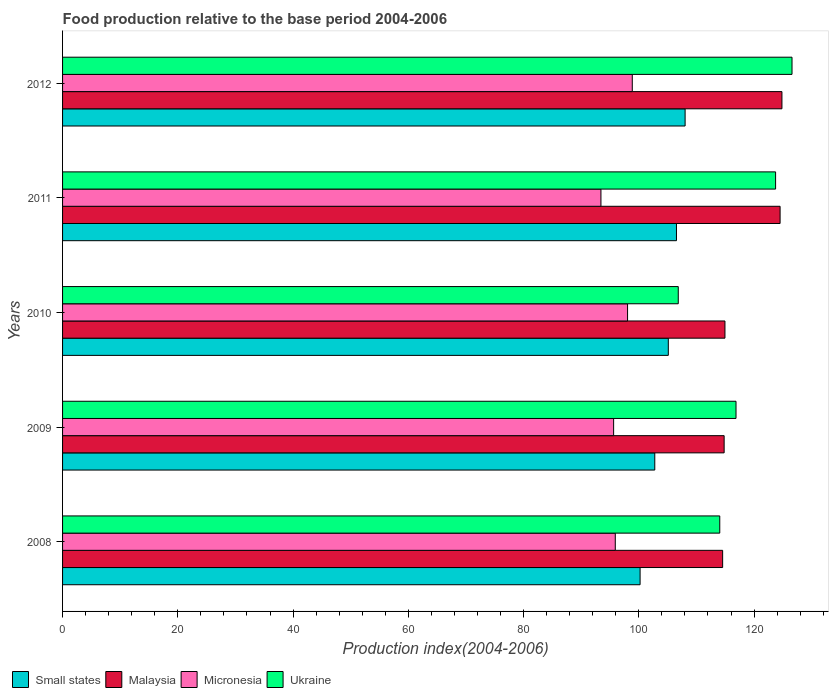Are the number of bars per tick equal to the number of legend labels?
Offer a terse response. Yes. Are the number of bars on each tick of the Y-axis equal?
Ensure brevity in your answer.  Yes. How many bars are there on the 2nd tick from the bottom?
Keep it short and to the point. 4. What is the food production index in Small states in 2011?
Your answer should be very brief. 106.54. Across all years, what is the maximum food production index in Ukraine?
Give a very brief answer. 126.59. Across all years, what is the minimum food production index in Malaysia?
Make the answer very short. 114.55. In which year was the food production index in Ukraine maximum?
Keep it short and to the point. 2012. In which year was the food production index in Small states minimum?
Offer a very short reply. 2008. What is the total food production index in Ukraine in the graph?
Your answer should be very brief. 588.1. What is the difference between the food production index in Small states in 2009 and that in 2011?
Give a very brief answer. -3.76. What is the difference between the food production index in Micronesia in 2010 and the food production index in Small states in 2008?
Keep it short and to the point. -2.17. What is the average food production index in Micronesia per year?
Your response must be concise. 96.38. In the year 2012, what is the difference between the food production index in Ukraine and food production index in Malaysia?
Give a very brief answer. 1.75. What is the ratio of the food production index in Micronesia in 2009 to that in 2012?
Give a very brief answer. 0.97. Is the food production index in Micronesia in 2011 less than that in 2012?
Your answer should be compact. Yes. What is the difference between the highest and the second highest food production index in Micronesia?
Make the answer very short. 0.82. What is the difference between the highest and the lowest food production index in Ukraine?
Provide a short and direct response. 19.74. In how many years, is the food production index in Ukraine greater than the average food production index in Ukraine taken over all years?
Give a very brief answer. 2. Is the sum of the food production index in Ukraine in 2008 and 2011 greater than the maximum food production index in Micronesia across all years?
Your response must be concise. Yes. Is it the case that in every year, the sum of the food production index in Ukraine and food production index in Small states is greater than the sum of food production index in Micronesia and food production index in Malaysia?
Provide a succinct answer. No. What does the 3rd bar from the top in 2012 represents?
Ensure brevity in your answer.  Malaysia. What does the 1st bar from the bottom in 2012 represents?
Keep it short and to the point. Small states. Is it the case that in every year, the sum of the food production index in Malaysia and food production index in Ukraine is greater than the food production index in Micronesia?
Your response must be concise. Yes. Are all the bars in the graph horizontal?
Your answer should be very brief. Yes. How many years are there in the graph?
Offer a very short reply. 5. Are the values on the major ticks of X-axis written in scientific E-notation?
Your answer should be compact. No. Does the graph contain any zero values?
Provide a short and direct response. No. Does the graph contain grids?
Provide a succinct answer. No. How many legend labels are there?
Your answer should be very brief. 4. What is the title of the graph?
Your answer should be compact. Food production relative to the base period 2004-2006. What is the label or title of the X-axis?
Ensure brevity in your answer.  Production index(2004-2006). What is the label or title of the Y-axis?
Your response must be concise. Years. What is the Production index(2004-2006) in Small states in 2008?
Offer a terse response. 100.22. What is the Production index(2004-2006) of Malaysia in 2008?
Offer a terse response. 114.55. What is the Production index(2004-2006) of Micronesia in 2008?
Your answer should be very brief. 95.92. What is the Production index(2004-2006) in Ukraine in 2008?
Offer a very short reply. 114.05. What is the Production index(2004-2006) of Small states in 2009?
Your answer should be very brief. 102.77. What is the Production index(2004-2006) of Malaysia in 2009?
Your answer should be compact. 114.81. What is the Production index(2004-2006) in Micronesia in 2009?
Make the answer very short. 95.63. What is the Production index(2004-2006) in Ukraine in 2009?
Make the answer very short. 116.87. What is the Production index(2004-2006) in Small states in 2010?
Offer a terse response. 105.12. What is the Production index(2004-2006) of Malaysia in 2010?
Your response must be concise. 114.95. What is the Production index(2004-2006) of Micronesia in 2010?
Make the answer very short. 98.05. What is the Production index(2004-2006) of Ukraine in 2010?
Your answer should be compact. 106.85. What is the Production index(2004-2006) in Small states in 2011?
Make the answer very short. 106.54. What is the Production index(2004-2006) in Malaysia in 2011?
Ensure brevity in your answer.  124.52. What is the Production index(2004-2006) in Micronesia in 2011?
Offer a very short reply. 93.43. What is the Production index(2004-2006) of Ukraine in 2011?
Offer a terse response. 123.74. What is the Production index(2004-2006) in Small states in 2012?
Offer a terse response. 108.04. What is the Production index(2004-2006) of Malaysia in 2012?
Ensure brevity in your answer.  124.84. What is the Production index(2004-2006) in Micronesia in 2012?
Your response must be concise. 98.87. What is the Production index(2004-2006) of Ukraine in 2012?
Give a very brief answer. 126.59. Across all years, what is the maximum Production index(2004-2006) in Small states?
Your answer should be compact. 108.04. Across all years, what is the maximum Production index(2004-2006) of Malaysia?
Your response must be concise. 124.84. Across all years, what is the maximum Production index(2004-2006) in Micronesia?
Your answer should be very brief. 98.87. Across all years, what is the maximum Production index(2004-2006) in Ukraine?
Ensure brevity in your answer.  126.59. Across all years, what is the minimum Production index(2004-2006) in Small states?
Offer a very short reply. 100.22. Across all years, what is the minimum Production index(2004-2006) of Malaysia?
Offer a terse response. 114.55. Across all years, what is the minimum Production index(2004-2006) of Micronesia?
Ensure brevity in your answer.  93.43. Across all years, what is the minimum Production index(2004-2006) of Ukraine?
Your answer should be compact. 106.85. What is the total Production index(2004-2006) of Small states in the graph?
Your answer should be compact. 522.69. What is the total Production index(2004-2006) in Malaysia in the graph?
Your answer should be compact. 593.67. What is the total Production index(2004-2006) in Micronesia in the graph?
Ensure brevity in your answer.  481.9. What is the total Production index(2004-2006) in Ukraine in the graph?
Give a very brief answer. 588.1. What is the difference between the Production index(2004-2006) in Small states in 2008 and that in 2009?
Offer a terse response. -2.55. What is the difference between the Production index(2004-2006) of Malaysia in 2008 and that in 2009?
Your answer should be very brief. -0.26. What is the difference between the Production index(2004-2006) of Micronesia in 2008 and that in 2009?
Provide a short and direct response. 0.29. What is the difference between the Production index(2004-2006) of Ukraine in 2008 and that in 2009?
Keep it short and to the point. -2.82. What is the difference between the Production index(2004-2006) in Small states in 2008 and that in 2010?
Give a very brief answer. -4.9. What is the difference between the Production index(2004-2006) of Micronesia in 2008 and that in 2010?
Offer a terse response. -2.13. What is the difference between the Production index(2004-2006) of Small states in 2008 and that in 2011?
Your answer should be compact. -6.31. What is the difference between the Production index(2004-2006) of Malaysia in 2008 and that in 2011?
Your answer should be very brief. -9.97. What is the difference between the Production index(2004-2006) of Micronesia in 2008 and that in 2011?
Offer a terse response. 2.49. What is the difference between the Production index(2004-2006) of Ukraine in 2008 and that in 2011?
Offer a terse response. -9.69. What is the difference between the Production index(2004-2006) in Small states in 2008 and that in 2012?
Provide a succinct answer. -7.81. What is the difference between the Production index(2004-2006) of Malaysia in 2008 and that in 2012?
Ensure brevity in your answer.  -10.29. What is the difference between the Production index(2004-2006) of Micronesia in 2008 and that in 2012?
Your answer should be very brief. -2.95. What is the difference between the Production index(2004-2006) of Ukraine in 2008 and that in 2012?
Your response must be concise. -12.54. What is the difference between the Production index(2004-2006) of Small states in 2009 and that in 2010?
Keep it short and to the point. -2.35. What is the difference between the Production index(2004-2006) in Malaysia in 2009 and that in 2010?
Offer a terse response. -0.14. What is the difference between the Production index(2004-2006) in Micronesia in 2009 and that in 2010?
Your response must be concise. -2.42. What is the difference between the Production index(2004-2006) in Ukraine in 2009 and that in 2010?
Provide a succinct answer. 10.02. What is the difference between the Production index(2004-2006) of Small states in 2009 and that in 2011?
Offer a very short reply. -3.76. What is the difference between the Production index(2004-2006) of Malaysia in 2009 and that in 2011?
Provide a short and direct response. -9.71. What is the difference between the Production index(2004-2006) in Ukraine in 2009 and that in 2011?
Keep it short and to the point. -6.87. What is the difference between the Production index(2004-2006) of Small states in 2009 and that in 2012?
Make the answer very short. -5.26. What is the difference between the Production index(2004-2006) in Malaysia in 2009 and that in 2012?
Your response must be concise. -10.03. What is the difference between the Production index(2004-2006) in Micronesia in 2009 and that in 2012?
Provide a short and direct response. -3.24. What is the difference between the Production index(2004-2006) in Ukraine in 2009 and that in 2012?
Give a very brief answer. -9.72. What is the difference between the Production index(2004-2006) of Small states in 2010 and that in 2011?
Offer a very short reply. -1.41. What is the difference between the Production index(2004-2006) of Malaysia in 2010 and that in 2011?
Your answer should be compact. -9.57. What is the difference between the Production index(2004-2006) in Micronesia in 2010 and that in 2011?
Your response must be concise. 4.62. What is the difference between the Production index(2004-2006) in Ukraine in 2010 and that in 2011?
Offer a very short reply. -16.89. What is the difference between the Production index(2004-2006) in Small states in 2010 and that in 2012?
Keep it short and to the point. -2.91. What is the difference between the Production index(2004-2006) of Malaysia in 2010 and that in 2012?
Give a very brief answer. -9.89. What is the difference between the Production index(2004-2006) of Micronesia in 2010 and that in 2012?
Keep it short and to the point. -0.82. What is the difference between the Production index(2004-2006) in Ukraine in 2010 and that in 2012?
Your response must be concise. -19.74. What is the difference between the Production index(2004-2006) of Small states in 2011 and that in 2012?
Your answer should be compact. -1.5. What is the difference between the Production index(2004-2006) in Malaysia in 2011 and that in 2012?
Your answer should be very brief. -0.32. What is the difference between the Production index(2004-2006) of Micronesia in 2011 and that in 2012?
Give a very brief answer. -5.44. What is the difference between the Production index(2004-2006) in Ukraine in 2011 and that in 2012?
Ensure brevity in your answer.  -2.85. What is the difference between the Production index(2004-2006) of Small states in 2008 and the Production index(2004-2006) of Malaysia in 2009?
Make the answer very short. -14.59. What is the difference between the Production index(2004-2006) of Small states in 2008 and the Production index(2004-2006) of Micronesia in 2009?
Provide a short and direct response. 4.59. What is the difference between the Production index(2004-2006) in Small states in 2008 and the Production index(2004-2006) in Ukraine in 2009?
Provide a short and direct response. -16.65. What is the difference between the Production index(2004-2006) in Malaysia in 2008 and the Production index(2004-2006) in Micronesia in 2009?
Offer a very short reply. 18.92. What is the difference between the Production index(2004-2006) in Malaysia in 2008 and the Production index(2004-2006) in Ukraine in 2009?
Offer a very short reply. -2.32. What is the difference between the Production index(2004-2006) of Micronesia in 2008 and the Production index(2004-2006) of Ukraine in 2009?
Make the answer very short. -20.95. What is the difference between the Production index(2004-2006) in Small states in 2008 and the Production index(2004-2006) in Malaysia in 2010?
Provide a short and direct response. -14.73. What is the difference between the Production index(2004-2006) in Small states in 2008 and the Production index(2004-2006) in Micronesia in 2010?
Keep it short and to the point. 2.17. What is the difference between the Production index(2004-2006) of Small states in 2008 and the Production index(2004-2006) of Ukraine in 2010?
Offer a very short reply. -6.63. What is the difference between the Production index(2004-2006) of Malaysia in 2008 and the Production index(2004-2006) of Micronesia in 2010?
Keep it short and to the point. 16.5. What is the difference between the Production index(2004-2006) of Malaysia in 2008 and the Production index(2004-2006) of Ukraine in 2010?
Your answer should be very brief. 7.7. What is the difference between the Production index(2004-2006) of Micronesia in 2008 and the Production index(2004-2006) of Ukraine in 2010?
Give a very brief answer. -10.93. What is the difference between the Production index(2004-2006) of Small states in 2008 and the Production index(2004-2006) of Malaysia in 2011?
Provide a short and direct response. -24.3. What is the difference between the Production index(2004-2006) in Small states in 2008 and the Production index(2004-2006) in Micronesia in 2011?
Provide a succinct answer. 6.79. What is the difference between the Production index(2004-2006) of Small states in 2008 and the Production index(2004-2006) of Ukraine in 2011?
Your answer should be very brief. -23.52. What is the difference between the Production index(2004-2006) of Malaysia in 2008 and the Production index(2004-2006) of Micronesia in 2011?
Ensure brevity in your answer.  21.12. What is the difference between the Production index(2004-2006) of Malaysia in 2008 and the Production index(2004-2006) of Ukraine in 2011?
Provide a short and direct response. -9.19. What is the difference between the Production index(2004-2006) of Micronesia in 2008 and the Production index(2004-2006) of Ukraine in 2011?
Provide a short and direct response. -27.82. What is the difference between the Production index(2004-2006) in Small states in 2008 and the Production index(2004-2006) in Malaysia in 2012?
Your answer should be very brief. -24.62. What is the difference between the Production index(2004-2006) of Small states in 2008 and the Production index(2004-2006) of Micronesia in 2012?
Make the answer very short. 1.35. What is the difference between the Production index(2004-2006) of Small states in 2008 and the Production index(2004-2006) of Ukraine in 2012?
Make the answer very short. -26.37. What is the difference between the Production index(2004-2006) of Malaysia in 2008 and the Production index(2004-2006) of Micronesia in 2012?
Your response must be concise. 15.68. What is the difference between the Production index(2004-2006) in Malaysia in 2008 and the Production index(2004-2006) in Ukraine in 2012?
Your answer should be very brief. -12.04. What is the difference between the Production index(2004-2006) in Micronesia in 2008 and the Production index(2004-2006) in Ukraine in 2012?
Provide a succinct answer. -30.67. What is the difference between the Production index(2004-2006) of Small states in 2009 and the Production index(2004-2006) of Malaysia in 2010?
Your answer should be compact. -12.18. What is the difference between the Production index(2004-2006) of Small states in 2009 and the Production index(2004-2006) of Micronesia in 2010?
Offer a terse response. 4.72. What is the difference between the Production index(2004-2006) in Small states in 2009 and the Production index(2004-2006) in Ukraine in 2010?
Make the answer very short. -4.08. What is the difference between the Production index(2004-2006) in Malaysia in 2009 and the Production index(2004-2006) in Micronesia in 2010?
Your response must be concise. 16.76. What is the difference between the Production index(2004-2006) in Malaysia in 2009 and the Production index(2004-2006) in Ukraine in 2010?
Ensure brevity in your answer.  7.96. What is the difference between the Production index(2004-2006) of Micronesia in 2009 and the Production index(2004-2006) of Ukraine in 2010?
Offer a very short reply. -11.22. What is the difference between the Production index(2004-2006) in Small states in 2009 and the Production index(2004-2006) in Malaysia in 2011?
Offer a very short reply. -21.75. What is the difference between the Production index(2004-2006) in Small states in 2009 and the Production index(2004-2006) in Micronesia in 2011?
Your response must be concise. 9.34. What is the difference between the Production index(2004-2006) of Small states in 2009 and the Production index(2004-2006) of Ukraine in 2011?
Give a very brief answer. -20.97. What is the difference between the Production index(2004-2006) in Malaysia in 2009 and the Production index(2004-2006) in Micronesia in 2011?
Provide a short and direct response. 21.38. What is the difference between the Production index(2004-2006) in Malaysia in 2009 and the Production index(2004-2006) in Ukraine in 2011?
Ensure brevity in your answer.  -8.93. What is the difference between the Production index(2004-2006) of Micronesia in 2009 and the Production index(2004-2006) of Ukraine in 2011?
Your answer should be very brief. -28.11. What is the difference between the Production index(2004-2006) in Small states in 2009 and the Production index(2004-2006) in Malaysia in 2012?
Make the answer very short. -22.07. What is the difference between the Production index(2004-2006) in Small states in 2009 and the Production index(2004-2006) in Micronesia in 2012?
Provide a succinct answer. 3.9. What is the difference between the Production index(2004-2006) of Small states in 2009 and the Production index(2004-2006) of Ukraine in 2012?
Make the answer very short. -23.82. What is the difference between the Production index(2004-2006) in Malaysia in 2009 and the Production index(2004-2006) in Micronesia in 2012?
Keep it short and to the point. 15.94. What is the difference between the Production index(2004-2006) of Malaysia in 2009 and the Production index(2004-2006) of Ukraine in 2012?
Your answer should be compact. -11.78. What is the difference between the Production index(2004-2006) of Micronesia in 2009 and the Production index(2004-2006) of Ukraine in 2012?
Your answer should be very brief. -30.96. What is the difference between the Production index(2004-2006) in Small states in 2010 and the Production index(2004-2006) in Malaysia in 2011?
Keep it short and to the point. -19.4. What is the difference between the Production index(2004-2006) in Small states in 2010 and the Production index(2004-2006) in Micronesia in 2011?
Your answer should be very brief. 11.69. What is the difference between the Production index(2004-2006) in Small states in 2010 and the Production index(2004-2006) in Ukraine in 2011?
Your answer should be very brief. -18.62. What is the difference between the Production index(2004-2006) in Malaysia in 2010 and the Production index(2004-2006) in Micronesia in 2011?
Offer a terse response. 21.52. What is the difference between the Production index(2004-2006) of Malaysia in 2010 and the Production index(2004-2006) of Ukraine in 2011?
Make the answer very short. -8.79. What is the difference between the Production index(2004-2006) in Micronesia in 2010 and the Production index(2004-2006) in Ukraine in 2011?
Make the answer very short. -25.69. What is the difference between the Production index(2004-2006) in Small states in 2010 and the Production index(2004-2006) in Malaysia in 2012?
Your answer should be compact. -19.72. What is the difference between the Production index(2004-2006) in Small states in 2010 and the Production index(2004-2006) in Micronesia in 2012?
Ensure brevity in your answer.  6.25. What is the difference between the Production index(2004-2006) in Small states in 2010 and the Production index(2004-2006) in Ukraine in 2012?
Ensure brevity in your answer.  -21.47. What is the difference between the Production index(2004-2006) of Malaysia in 2010 and the Production index(2004-2006) of Micronesia in 2012?
Your answer should be compact. 16.08. What is the difference between the Production index(2004-2006) of Malaysia in 2010 and the Production index(2004-2006) of Ukraine in 2012?
Offer a very short reply. -11.64. What is the difference between the Production index(2004-2006) of Micronesia in 2010 and the Production index(2004-2006) of Ukraine in 2012?
Offer a terse response. -28.54. What is the difference between the Production index(2004-2006) in Small states in 2011 and the Production index(2004-2006) in Malaysia in 2012?
Provide a short and direct response. -18.3. What is the difference between the Production index(2004-2006) in Small states in 2011 and the Production index(2004-2006) in Micronesia in 2012?
Make the answer very short. 7.67. What is the difference between the Production index(2004-2006) of Small states in 2011 and the Production index(2004-2006) of Ukraine in 2012?
Your answer should be compact. -20.05. What is the difference between the Production index(2004-2006) in Malaysia in 2011 and the Production index(2004-2006) in Micronesia in 2012?
Your answer should be compact. 25.65. What is the difference between the Production index(2004-2006) of Malaysia in 2011 and the Production index(2004-2006) of Ukraine in 2012?
Your response must be concise. -2.07. What is the difference between the Production index(2004-2006) in Micronesia in 2011 and the Production index(2004-2006) in Ukraine in 2012?
Make the answer very short. -33.16. What is the average Production index(2004-2006) of Small states per year?
Provide a succinct answer. 104.54. What is the average Production index(2004-2006) in Malaysia per year?
Your answer should be compact. 118.73. What is the average Production index(2004-2006) of Micronesia per year?
Ensure brevity in your answer.  96.38. What is the average Production index(2004-2006) in Ukraine per year?
Provide a short and direct response. 117.62. In the year 2008, what is the difference between the Production index(2004-2006) of Small states and Production index(2004-2006) of Malaysia?
Provide a short and direct response. -14.33. In the year 2008, what is the difference between the Production index(2004-2006) in Small states and Production index(2004-2006) in Micronesia?
Provide a short and direct response. 4.3. In the year 2008, what is the difference between the Production index(2004-2006) of Small states and Production index(2004-2006) of Ukraine?
Your answer should be very brief. -13.83. In the year 2008, what is the difference between the Production index(2004-2006) in Malaysia and Production index(2004-2006) in Micronesia?
Give a very brief answer. 18.63. In the year 2008, what is the difference between the Production index(2004-2006) of Micronesia and Production index(2004-2006) of Ukraine?
Make the answer very short. -18.13. In the year 2009, what is the difference between the Production index(2004-2006) in Small states and Production index(2004-2006) in Malaysia?
Keep it short and to the point. -12.04. In the year 2009, what is the difference between the Production index(2004-2006) in Small states and Production index(2004-2006) in Micronesia?
Make the answer very short. 7.14. In the year 2009, what is the difference between the Production index(2004-2006) of Small states and Production index(2004-2006) of Ukraine?
Provide a succinct answer. -14.1. In the year 2009, what is the difference between the Production index(2004-2006) in Malaysia and Production index(2004-2006) in Micronesia?
Provide a short and direct response. 19.18. In the year 2009, what is the difference between the Production index(2004-2006) of Malaysia and Production index(2004-2006) of Ukraine?
Your answer should be compact. -2.06. In the year 2009, what is the difference between the Production index(2004-2006) of Micronesia and Production index(2004-2006) of Ukraine?
Your answer should be very brief. -21.24. In the year 2010, what is the difference between the Production index(2004-2006) in Small states and Production index(2004-2006) in Malaysia?
Your answer should be compact. -9.83. In the year 2010, what is the difference between the Production index(2004-2006) of Small states and Production index(2004-2006) of Micronesia?
Your answer should be compact. 7.07. In the year 2010, what is the difference between the Production index(2004-2006) in Small states and Production index(2004-2006) in Ukraine?
Keep it short and to the point. -1.73. In the year 2010, what is the difference between the Production index(2004-2006) in Malaysia and Production index(2004-2006) in Micronesia?
Provide a succinct answer. 16.9. In the year 2010, what is the difference between the Production index(2004-2006) in Malaysia and Production index(2004-2006) in Ukraine?
Your response must be concise. 8.1. In the year 2010, what is the difference between the Production index(2004-2006) in Micronesia and Production index(2004-2006) in Ukraine?
Ensure brevity in your answer.  -8.8. In the year 2011, what is the difference between the Production index(2004-2006) in Small states and Production index(2004-2006) in Malaysia?
Keep it short and to the point. -17.98. In the year 2011, what is the difference between the Production index(2004-2006) of Small states and Production index(2004-2006) of Micronesia?
Make the answer very short. 13.11. In the year 2011, what is the difference between the Production index(2004-2006) in Small states and Production index(2004-2006) in Ukraine?
Your response must be concise. -17.2. In the year 2011, what is the difference between the Production index(2004-2006) of Malaysia and Production index(2004-2006) of Micronesia?
Provide a succinct answer. 31.09. In the year 2011, what is the difference between the Production index(2004-2006) of Malaysia and Production index(2004-2006) of Ukraine?
Your answer should be very brief. 0.78. In the year 2011, what is the difference between the Production index(2004-2006) of Micronesia and Production index(2004-2006) of Ukraine?
Your answer should be very brief. -30.31. In the year 2012, what is the difference between the Production index(2004-2006) in Small states and Production index(2004-2006) in Malaysia?
Ensure brevity in your answer.  -16.8. In the year 2012, what is the difference between the Production index(2004-2006) in Small states and Production index(2004-2006) in Micronesia?
Keep it short and to the point. 9.17. In the year 2012, what is the difference between the Production index(2004-2006) in Small states and Production index(2004-2006) in Ukraine?
Offer a terse response. -18.55. In the year 2012, what is the difference between the Production index(2004-2006) in Malaysia and Production index(2004-2006) in Micronesia?
Provide a succinct answer. 25.97. In the year 2012, what is the difference between the Production index(2004-2006) of Malaysia and Production index(2004-2006) of Ukraine?
Your response must be concise. -1.75. In the year 2012, what is the difference between the Production index(2004-2006) of Micronesia and Production index(2004-2006) of Ukraine?
Keep it short and to the point. -27.72. What is the ratio of the Production index(2004-2006) of Small states in 2008 to that in 2009?
Ensure brevity in your answer.  0.98. What is the ratio of the Production index(2004-2006) in Malaysia in 2008 to that in 2009?
Offer a terse response. 1. What is the ratio of the Production index(2004-2006) in Ukraine in 2008 to that in 2009?
Provide a short and direct response. 0.98. What is the ratio of the Production index(2004-2006) of Small states in 2008 to that in 2010?
Provide a succinct answer. 0.95. What is the ratio of the Production index(2004-2006) in Micronesia in 2008 to that in 2010?
Give a very brief answer. 0.98. What is the ratio of the Production index(2004-2006) in Ukraine in 2008 to that in 2010?
Ensure brevity in your answer.  1.07. What is the ratio of the Production index(2004-2006) in Small states in 2008 to that in 2011?
Keep it short and to the point. 0.94. What is the ratio of the Production index(2004-2006) in Malaysia in 2008 to that in 2011?
Keep it short and to the point. 0.92. What is the ratio of the Production index(2004-2006) of Micronesia in 2008 to that in 2011?
Offer a terse response. 1.03. What is the ratio of the Production index(2004-2006) in Ukraine in 2008 to that in 2011?
Offer a very short reply. 0.92. What is the ratio of the Production index(2004-2006) in Small states in 2008 to that in 2012?
Provide a short and direct response. 0.93. What is the ratio of the Production index(2004-2006) in Malaysia in 2008 to that in 2012?
Offer a terse response. 0.92. What is the ratio of the Production index(2004-2006) of Micronesia in 2008 to that in 2012?
Make the answer very short. 0.97. What is the ratio of the Production index(2004-2006) of Ukraine in 2008 to that in 2012?
Make the answer very short. 0.9. What is the ratio of the Production index(2004-2006) of Small states in 2009 to that in 2010?
Your answer should be very brief. 0.98. What is the ratio of the Production index(2004-2006) of Micronesia in 2009 to that in 2010?
Offer a very short reply. 0.98. What is the ratio of the Production index(2004-2006) in Ukraine in 2009 to that in 2010?
Provide a succinct answer. 1.09. What is the ratio of the Production index(2004-2006) of Small states in 2009 to that in 2011?
Offer a terse response. 0.96. What is the ratio of the Production index(2004-2006) in Malaysia in 2009 to that in 2011?
Your answer should be compact. 0.92. What is the ratio of the Production index(2004-2006) in Micronesia in 2009 to that in 2011?
Ensure brevity in your answer.  1.02. What is the ratio of the Production index(2004-2006) of Ukraine in 2009 to that in 2011?
Offer a very short reply. 0.94. What is the ratio of the Production index(2004-2006) of Small states in 2009 to that in 2012?
Make the answer very short. 0.95. What is the ratio of the Production index(2004-2006) of Malaysia in 2009 to that in 2012?
Offer a terse response. 0.92. What is the ratio of the Production index(2004-2006) in Micronesia in 2009 to that in 2012?
Your answer should be compact. 0.97. What is the ratio of the Production index(2004-2006) in Ukraine in 2009 to that in 2012?
Your response must be concise. 0.92. What is the ratio of the Production index(2004-2006) in Small states in 2010 to that in 2011?
Your answer should be compact. 0.99. What is the ratio of the Production index(2004-2006) of Micronesia in 2010 to that in 2011?
Provide a short and direct response. 1.05. What is the ratio of the Production index(2004-2006) in Ukraine in 2010 to that in 2011?
Your answer should be compact. 0.86. What is the ratio of the Production index(2004-2006) of Small states in 2010 to that in 2012?
Ensure brevity in your answer.  0.97. What is the ratio of the Production index(2004-2006) of Malaysia in 2010 to that in 2012?
Provide a succinct answer. 0.92. What is the ratio of the Production index(2004-2006) of Micronesia in 2010 to that in 2012?
Keep it short and to the point. 0.99. What is the ratio of the Production index(2004-2006) of Ukraine in 2010 to that in 2012?
Keep it short and to the point. 0.84. What is the ratio of the Production index(2004-2006) of Small states in 2011 to that in 2012?
Provide a short and direct response. 0.99. What is the ratio of the Production index(2004-2006) in Malaysia in 2011 to that in 2012?
Your response must be concise. 1. What is the ratio of the Production index(2004-2006) in Micronesia in 2011 to that in 2012?
Keep it short and to the point. 0.94. What is the ratio of the Production index(2004-2006) of Ukraine in 2011 to that in 2012?
Give a very brief answer. 0.98. What is the difference between the highest and the second highest Production index(2004-2006) in Small states?
Give a very brief answer. 1.5. What is the difference between the highest and the second highest Production index(2004-2006) in Malaysia?
Your answer should be compact. 0.32. What is the difference between the highest and the second highest Production index(2004-2006) in Micronesia?
Offer a very short reply. 0.82. What is the difference between the highest and the second highest Production index(2004-2006) of Ukraine?
Your answer should be very brief. 2.85. What is the difference between the highest and the lowest Production index(2004-2006) in Small states?
Offer a terse response. 7.81. What is the difference between the highest and the lowest Production index(2004-2006) of Malaysia?
Provide a succinct answer. 10.29. What is the difference between the highest and the lowest Production index(2004-2006) of Micronesia?
Provide a succinct answer. 5.44. What is the difference between the highest and the lowest Production index(2004-2006) in Ukraine?
Offer a terse response. 19.74. 